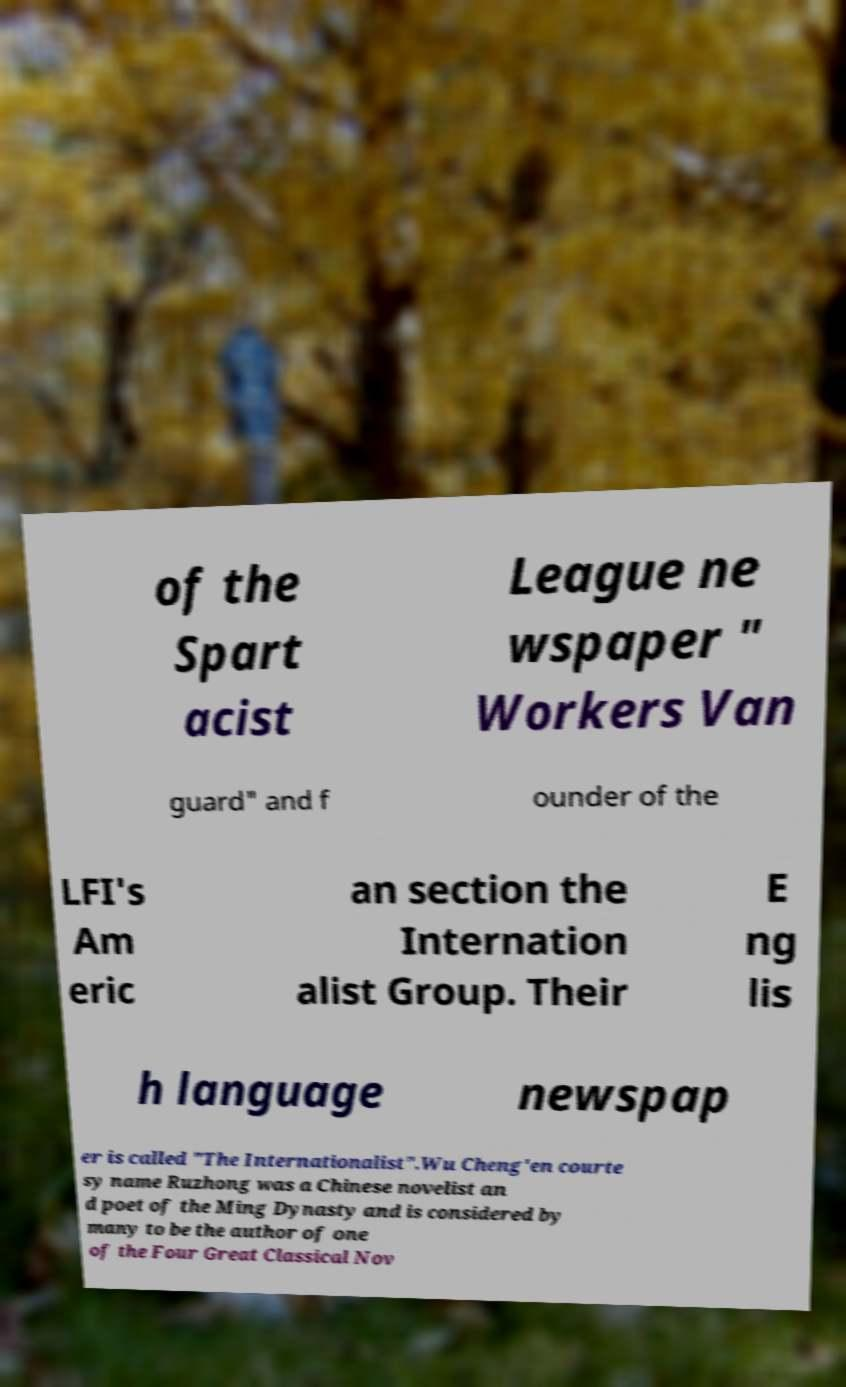Can you read and provide the text displayed in the image?This photo seems to have some interesting text. Can you extract and type it out for me? of the Spart acist League ne wspaper " Workers Van guard" and f ounder of the LFI's Am eric an section the Internation alist Group. Their E ng lis h language newspap er is called "The Internationalist".Wu Cheng'en courte sy name Ruzhong was a Chinese novelist an d poet of the Ming Dynasty and is considered by many to be the author of one of the Four Great Classical Nov 